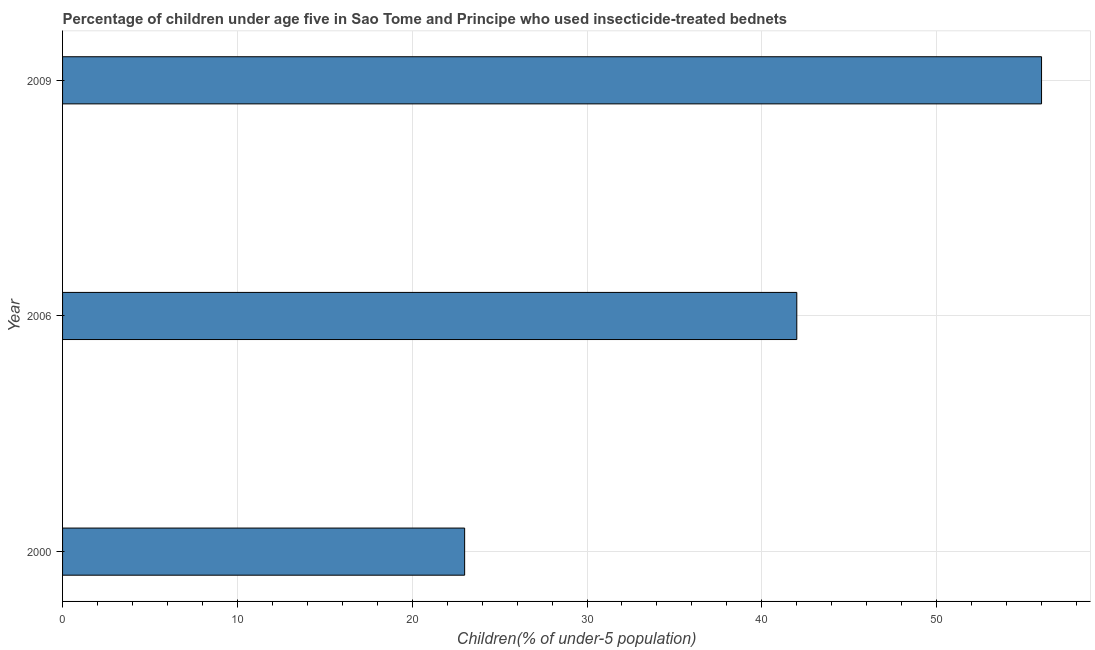Does the graph contain any zero values?
Keep it short and to the point. No. Does the graph contain grids?
Give a very brief answer. Yes. What is the title of the graph?
Make the answer very short. Percentage of children under age five in Sao Tome and Principe who used insecticide-treated bednets. What is the label or title of the X-axis?
Provide a short and direct response. Children(% of under-5 population). What is the percentage of children who use of insecticide-treated bed nets in 2006?
Provide a succinct answer. 42. Across all years, what is the maximum percentage of children who use of insecticide-treated bed nets?
Your answer should be very brief. 56. Across all years, what is the minimum percentage of children who use of insecticide-treated bed nets?
Your response must be concise. 23. What is the sum of the percentage of children who use of insecticide-treated bed nets?
Provide a short and direct response. 121. What is the difference between the percentage of children who use of insecticide-treated bed nets in 2000 and 2009?
Make the answer very short. -33. In how many years, is the percentage of children who use of insecticide-treated bed nets greater than 6 %?
Keep it short and to the point. 3. Do a majority of the years between 2000 and 2009 (inclusive) have percentage of children who use of insecticide-treated bed nets greater than 52 %?
Provide a short and direct response. No. What is the ratio of the percentage of children who use of insecticide-treated bed nets in 2000 to that in 2006?
Your answer should be compact. 0.55. Is the percentage of children who use of insecticide-treated bed nets in 2000 less than that in 2009?
Offer a very short reply. Yes. What is the difference between the highest and the second highest percentage of children who use of insecticide-treated bed nets?
Your response must be concise. 14. What is the difference between the highest and the lowest percentage of children who use of insecticide-treated bed nets?
Your response must be concise. 33. In how many years, is the percentage of children who use of insecticide-treated bed nets greater than the average percentage of children who use of insecticide-treated bed nets taken over all years?
Your response must be concise. 2. How many bars are there?
Your answer should be very brief. 3. Are all the bars in the graph horizontal?
Keep it short and to the point. Yes. What is the difference between two consecutive major ticks on the X-axis?
Your answer should be very brief. 10. What is the Children(% of under-5 population) of 2006?
Offer a terse response. 42. What is the difference between the Children(% of under-5 population) in 2000 and 2006?
Offer a terse response. -19. What is the difference between the Children(% of under-5 population) in 2000 and 2009?
Your answer should be very brief. -33. What is the ratio of the Children(% of under-5 population) in 2000 to that in 2006?
Provide a short and direct response. 0.55. What is the ratio of the Children(% of under-5 population) in 2000 to that in 2009?
Offer a very short reply. 0.41. 